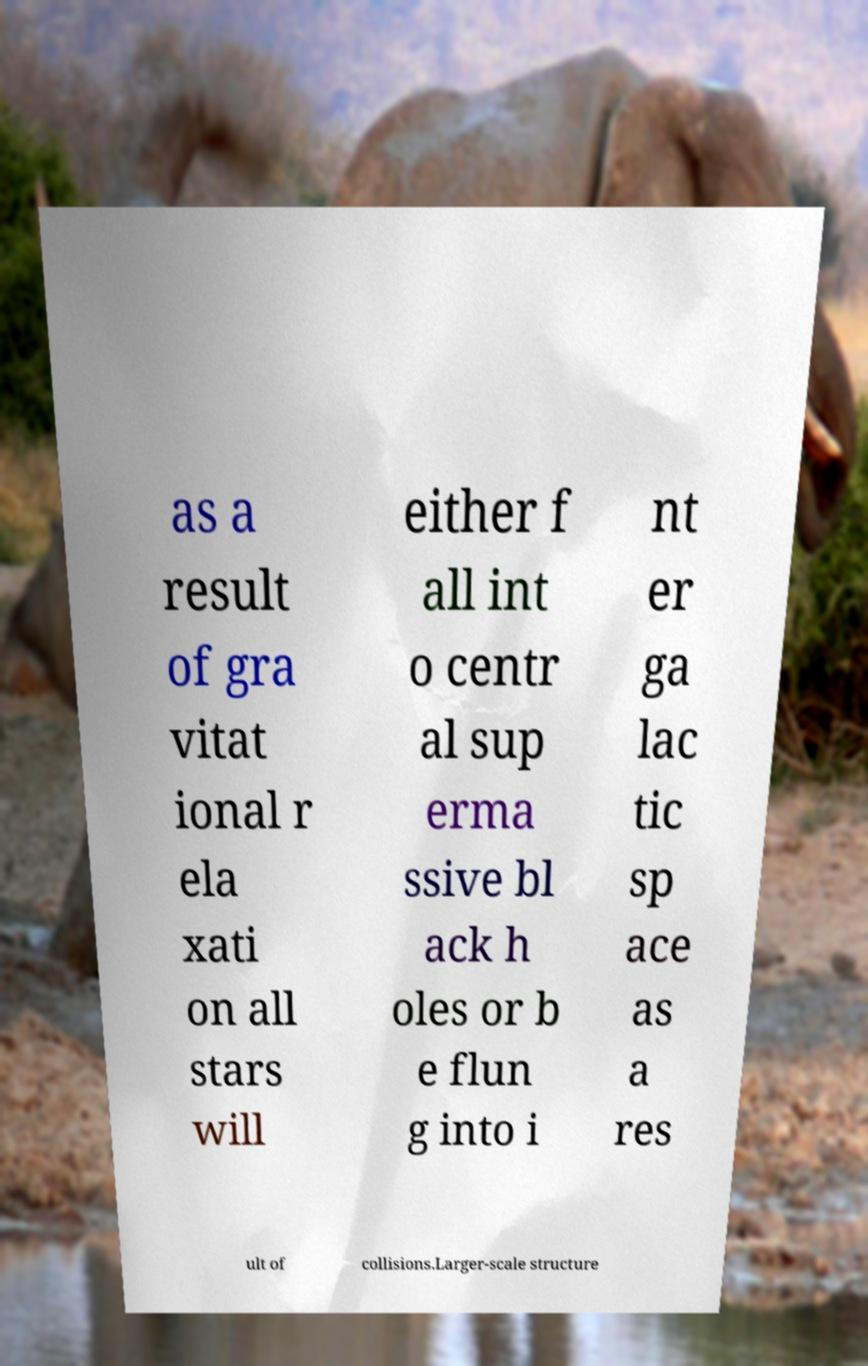Please read and relay the text visible in this image. What does it say? as a result of gra vitat ional r ela xati on all stars will either f all int o centr al sup erma ssive bl ack h oles or b e flun g into i nt er ga lac tic sp ace as a res ult of collisions.Larger-scale structure 